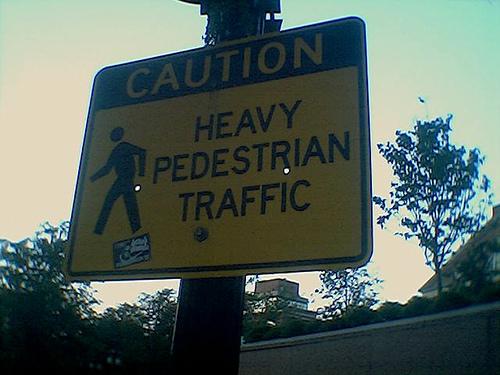What color is the sign?
Answer briefly. Yellow. Has the sign been vandalized?
Keep it brief. Yes. What kind of traffic is there?
Be succinct. Pedestrian. What does this sign say to watch out for?
Be succinct. Pedestrians. 